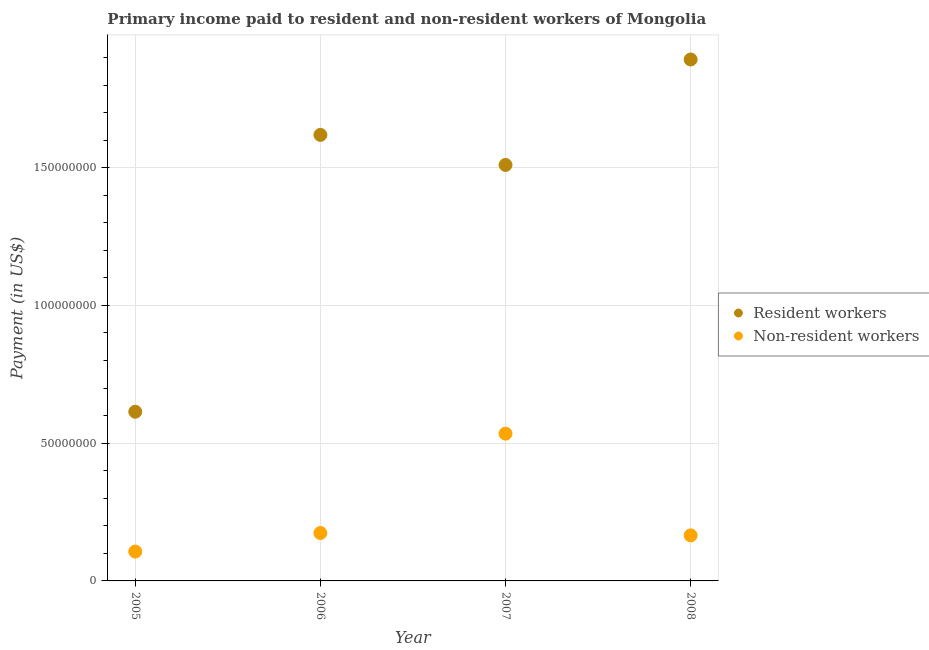What is the payment made to resident workers in 2005?
Your answer should be very brief. 6.14e+07. Across all years, what is the maximum payment made to non-resident workers?
Your answer should be very brief. 5.35e+07. Across all years, what is the minimum payment made to non-resident workers?
Provide a short and direct response. 1.07e+07. In which year was the payment made to resident workers maximum?
Ensure brevity in your answer.  2008. In which year was the payment made to non-resident workers minimum?
Make the answer very short. 2005. What is the total payment made to non-resident workers in the graph?
Give a very brief answer. 9.80e+07. What is the difference between the payment made to resident workers in 2005 and that in 2007?
Your answer should be very brief. -8.96e+07. What is the difference between the payment made to non-resident workers in 2006 and the payment made to resident workers in 2008?
Your answer should be compact. -1.72e+08. What is the average payment made to non-resident workers per year?
Offer a very short reply. 2.45e+07. In the year 2007, what is the difference between the payment made to non-resident workers and payment made to resident workers?
Give a very brief answer. -9.75e+07. What is the ratio of the payment made to resident workers in 2006 to that in 2007?
Your response must be concise. 1.07. What is the difference between the highest and the second highest payment made to resident workers?
Make the answer very short. 2.74e+07. What is the difference between the highest and the lowest payment made to non-resident workers?
Ensure brevity in your answer.  4.28e+07. In how many years, is the payment made to non-resident workers greater than the average payment made to non-resident workers taken over all years?
Give a very brief answer. 1. Is the sum of the payment made to non-resident workers in 2005 and 2006 greater than the maximum payment made to resident workers across all years?
Ensure brevity in your answer.  No. Does the payment made to resident workers monotonically increase over the years?
Your answer should be very brief. No. Is the payment made to non-resident workers strictly greater than the payment made to resident workers over the years?
Give a very brief answer. No. Is the payment made to non-resident workers strictly less than the payment made to resident workers over the years?
Ensure brevity in your answer.  Yes. How many years are there in the graph?
Provide a short and direct response. 4. What is the difference between two consecutive major ticks on the Y-axis?
Make the answer very short. 5.00e+07. Are the values on the major ticks of Y-axis written in scientific E-notation?
Your answer should be very brief. No. How many legend labels are there?
Keep it short and to the point. 2. How are the legend labels stacked?
Offer a terse response. Vertical. What is the title of the graph?
Ensure brevity in your answer.  Primary income paid to resident and non-resident workers of Mongolia. Does "Registered firms" appear as one of the legend labels in the graph?
Provide a succinct answer. No. What is the label or title of the X-axis?
Provide a succinct answer. Year. What is the label or title of the Y-axis?
Offer a terse response. Payment (in US$). What is the Payment (in US$) in Resident workers in 2005?
Make the answer very short. 6.14e+07. What is the Payment (in US$) in Non-resident workers in 2005?
Your response must be concise. 1.07e+07. What is the Payment (in US$) of Resident workers in 2006?
Keep it short and to the point. 1.62e+08. What is the Payment (in US$) in Non-resident workers in 2006?
Your response must be concise. 1.74e+07. What is the Payment (in US$) of Resident workers in 2007?
Your answer should be compact. 1.51e+08. What is the Payment (in US$) in Non-resident workers in 2007?
Provide a succinct answer. 5.35e+07. What is the Payment (in US$) in Resident workers in 2008?
Your answer should be compact. 1.89e+08. What is the Payment (in US$) of Non-resident workers in 2008?
Make the answer very short. 1.65e+07. Across all years, what is the maximum Payment (in US$) in Resident workers?
Your answer should be compact. 1.89e+08. Across all years, what is the maximum Payment (in US$) of Non-resident workers?
Offer a terse response. 5.35e+07. Across all years, what is the minimum Payment (in US$) in Resident workers?
Your answer should be very brief. 6.14e+07. Across all years, what is the minimum Payment (in US$) of Non-resident workers?
Give a very brief answer. 1.07e+07. What is the total Payment (in US$) of Resident workers in the graph?
Make the answer very short. 5.64e+08. What is the total Payment (in US$) of Non-resident workers in the graph?
Provide a short and direct response. 9.80e+07. What is the difference between the Payment (in US$) in Resident workers in 2005 and that in 2006?
Make the answer very short. -1.00e+08. What is the difference between the Payment (in US$) of Non-resident workers in 2005 and that in 2006?
Keep it short and to the point. -6.73e+06. What is the difference between the Payment (in US$) of Resident workers in 2005 and that in 2007?
Your response must be concise. -8.96e+07. What is the difference between the Payment (in US$) in Non-resident workers in 2005 and that in 2007?
Keep it short and to the point. -4.28e+07. What is the difference between the Payment (in US$) in Resident workers in 2005 and that in 2008?
Your answer should be very brief. -1.28e+08. What is the difference between the Payment (in US$) of Non-resident workers in 2005 and that in 2008?
Make the answer very short. -5.88e+06. What is the difference between the Payment (in US$) of Resident workers in 2006 and that in 2007?
Your response must be concise. 1.09e+07. What is the difference between the Payment (in US$) of Non-resident workers in 2006 and that in 2007?
Offer a very short reply. -3.61e+07. What is the difference between the Payment (in US$) of Resident workers in 2006 and that in 2008?
Provide a succinct answer. -2.74e+07. What is the difference between the Payment (in US$) of Non-resident workers in 2006 and that in 2008?
Offer a very short reply. 8.54e+05. What is the difference between the Payment (in US$) of Resident workers in 2007 and that in 2008?
Keep it short and to the point. -3.83e+07. What is the difference between the Payment (in US$) in Non-resident workers in 2007 and that in 2008?
Keep it short and to the point. 3.69e+07. What is the difference between the Payment (in US$) of Resident workers in 2005 and the Payment (in US$) of Non-resident workers in 2006?
Give a very brief answer. 4.40e+07. What is the difference between the Payment (in US$) of Resident workers in 2005 and the Payment (in US$) of Non-resident workers in 2007?
Keep it short and to the point. 7.95e+06. What is the difference between the Payment (in US$) in Resident workers in 2005 and the Payment (in US$) in Non-resident workers in 2008?
Your answer should be compact. 4.49e+07. What is the difference between the Payment (in US$) of Resident workers in 2006 and the Payment (in US$) of Non-resident workers in 2007?
Your response must be concise. 1.08e+08. What is the difference between the Payment (in US$) in Resident workers in 2006 and the Payment (in US$) in Non-resident workers in 2008?
Provide a short and direct response. 1.45e+08. What is the difference between the Payment (in US$) of Resident workers in 2007 and the Payment (in US$) of Non-resident workers in 2008?
Offer a terse response. 1.34e+08. What is the average Payment (in US$) of Resident workers per year?
Provide a succinct answer. 1.41e+08. What is the average Payment (in US$) of Non-resident workers per year?
Your response must be concise. 2.45e+07. In the year 2005, what is the difference between the Payment (in US$) in Resident workers and Payment (in US$) in Non-resident workers?
Provide a succinct answer. 5.08e+07. In the year 2006, what is the difference between the Payment (in US$) of Resident workers and Payment (in US$) of Non-resident workers?
Make the answer very short. 1.45e+08. In the year 2007, what is the difference between the Payment (in US$) in Resident workers and Payment (in US$) in Non-resident workers?
Your answer should be compact. 9.75e+07. In the year 2008, what is the difference between the Payment (in US$) in Resident workers and Payment (in US$) in Non-resident workers?
Provide a succinct answer. 1.73e+08. What is the ratio of the Payment (in US$) in Resident workers in 2005 to that in 2006?
Keep it short and to the point. 0.38. What is the ratio of the Payment (in US$) in Non-resident workers in 2005 to that in 2006?
Provide a short and direct response. 0.61. What is the ratio of the Payment (in US$) of Resident workers in 2005 to that in 2007?
Your answer should be very brief. 0.41. What is the ratio of the Payment (in US$) of Non-resident workers in 2005 to that in 2007?
Keep it short and to the point. 0.2. What is the ratio of the Payment (in US$) of Resident workers in 2005 to that in 2008?
Make the answer very short. 0.32. What is the ratio of the Payment (in US$) of Non-resident workers in 2005 to that in 2008?
Give a very brief answer. 0.64. What is the ratio of the Payment (in US$) in Resident workers in 2006 to that in 2007?
Ensure brevity in your answer.  1.07. What is the ratio of the Payment (in US$) in Non-resident workers in 2006 to that in 2007?
Ensure brevity in your answer.  0.33. What is the ratio of the Payment (in US$) of Resident workers in 2006 to that in 2008?
Offer a terse response. 0.86. What is the ratio of the Payment (in US$) in Non-resident workers in 2006 to that in 2008?
Ensure brevity in your answer.  1.05. What is the ratio of the Payment (in US$) of Resident workers in 2007 to that in 2008?
Offer a terse response. 0.8. What is the ratio of the Payment (in US$) of Non-resident workers in 2007 to that in 2008?
Your response must be concise. 3.23. What is the difference between the highest and the second highest Payment (in US$) of Resident workers?
Your response must be concise. 2.74e+07. What is the difference between the highest and the second highest Payment (in US$) in Non-resident workers?
Keep it short and to the point. 3.61e+07. What is the difference between the highest and the lowest Payment (in US$) in Resident workers?
Your response must be concise. 1.28e+08. What is the difference between the highest and the lowest Payment (in US$) in Non-resident workers?
Your answer should be compact. 4.28e+07. 